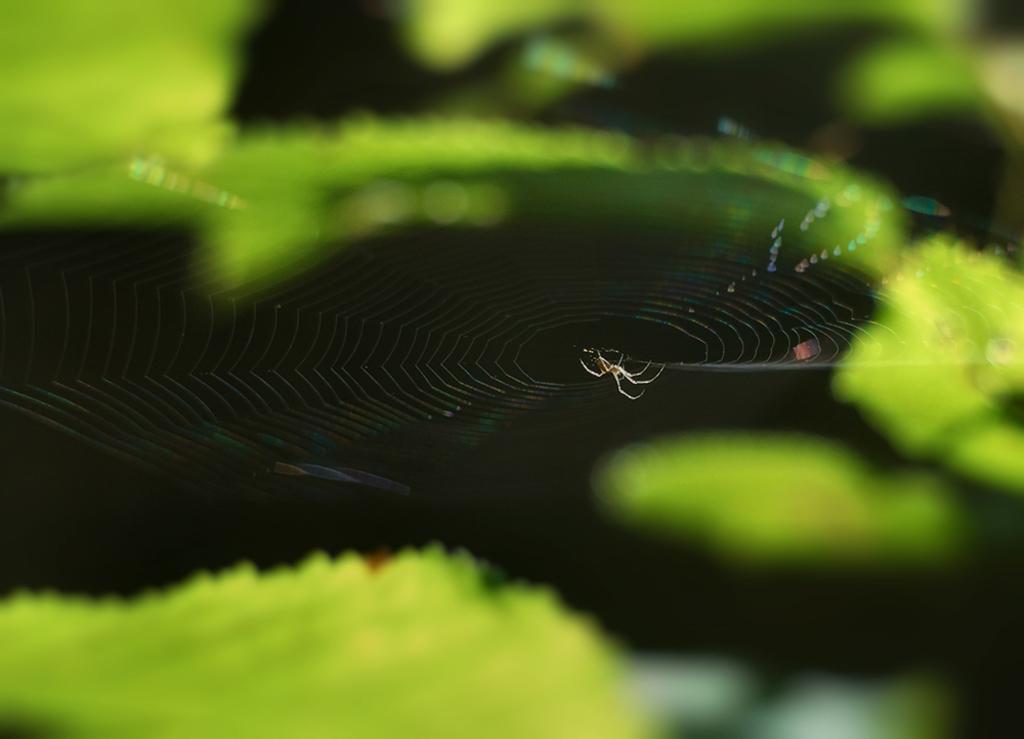Describe this image in one or two sentences. In this image I can see a spider and spider web. Background is in green and black color. 